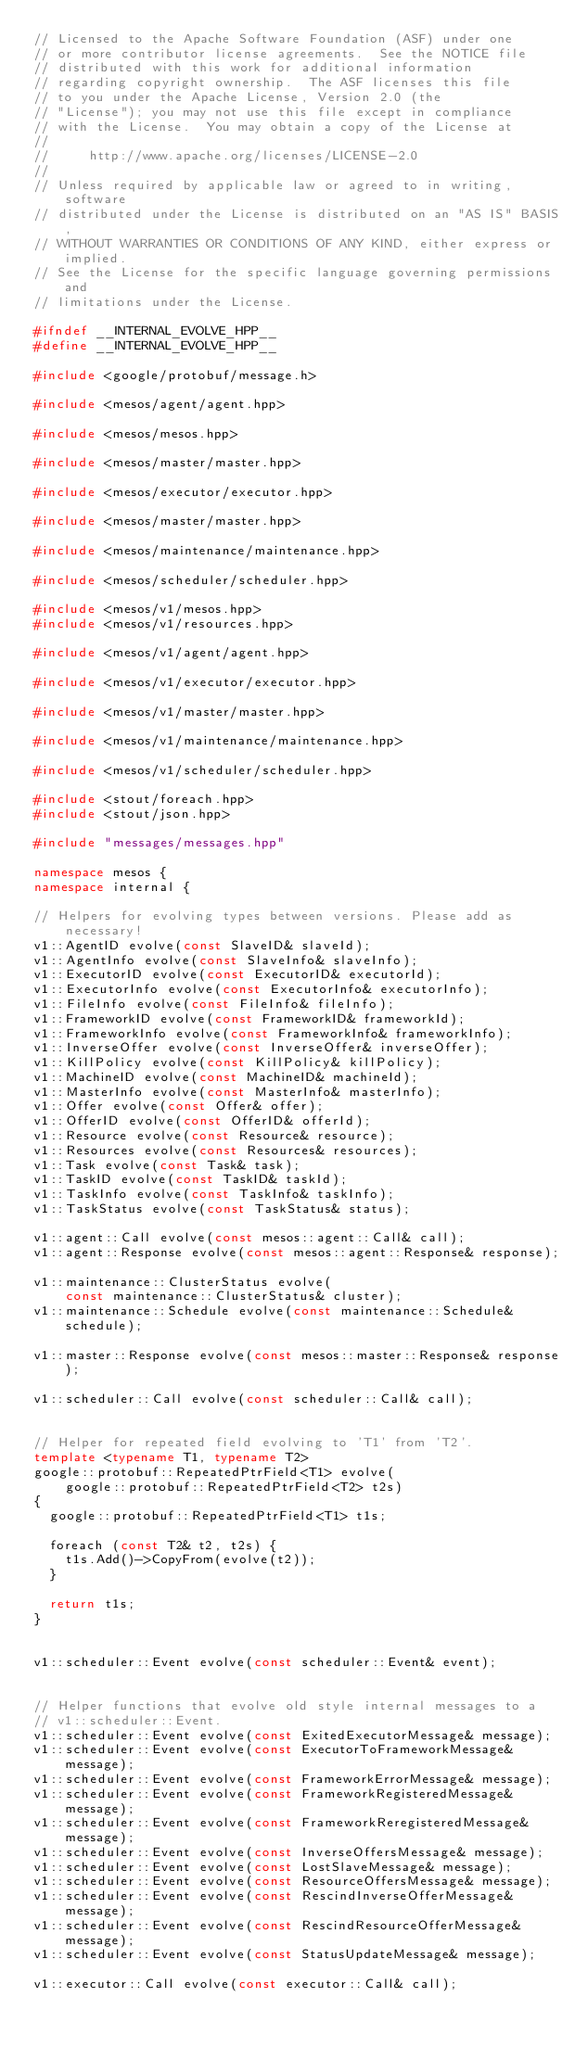Convert code to text. <code><loc_0><loc_0><loc_500><loc_500><_C++_>// Licensed to the Apache Software Foundation (ASF) under one
// or more contributor license agreements.  See the NOTICE file
// distributed with this work for additional information
// regarding copyright ownership.  The ASF licenses this file
// to you under the Apache License, Version 2.0 (the
// "License"); you may not use this file except in compliance
// with the License.  You may obtain a copy of the License at
//
//     http://www.apache.org/licenses/LICENSE-2.0
//
// Unless required by applicable law or agreed to in writing, software
// distributed under the License is distributed on an "AS IS" BASIS,
// WITHOUT WARRANTIES OR CONDITIONS OF ANY KIND, either express or implied.
// See the License for the specific language governing permissions and
// limitations under the License.

#ifndef __INTERNAL_EVOLVE_HPP__
#define __INTERNAL_EVOLVE_HPP__

#include <google/protobuf/message.h>

#include <mesos/agent/agent.hpp>

#include <mesos/mesos.hpp>

#include <mesos/master/master.hpp>

#include <mesos/executor/executor.hpp>

#include <mesos/master/master.hpp>

#include <mesos/maintenance/maintenance.hpp>

#include <mesos/scheduler/scheduler.hpp>

#include <mesos/v1/mesos.hpp>
#include <mesos/v1/resources.hpp>

#include <mesos/v1/agent/agent.hpp>

#include <mesos/v1/executor/executor.hpp>

#include <mesos/v1/master/master.hpp>

#include <mesos/v1/maintenance/maintenance.hpp>

#include <mesos/v1/scheduler/scheduler.hpp>

#include <stout/foreach.hpp>
#include <stout/json.hpp>

#include "messages/messages.hpp"

namespace mesos {
namespace internal {

// Helpers for evolving types between versions. Please add as necessary!
v1::AgentID evolve(const SlaveID& slaveId);
v1::AgentInfo evolve(const SlaveInfo& slaveInfo);
v1::ExecutorID evolve(const ExecutorID& executorId);
v1::ExecutorInfo evolve(const ExecutorInfo& executorInfo);
v1::FileInfo evolve(const FileInfo& fileInfo);
v1::FrameworkID evolve(const FrameworkID& frameworkId);
v1::FrameworkInfo evolve(const FrameworkInfo& frameworkInfo);
v1::InverseOffer evolve(const InverseOffer& inverseOffer);
v1::KillPolicy evolve(const KillPolicy& killPolicy);
v1::MachineID evolve(const MachineID& machineId);
v1::MasterInfo evolve(const MasterInfo& masterInfo);
v1::Offer evolve(const Offer& offer);
v1::OfferID evolve(const OfferID& offerId);
v1::Resource evolve(const Resource& resource);
v1::Resources evolve(const Resources& resources);
v1::Task evolve(const Task& task);
v1::TaskID evolve(const TaskID& taskId);
v1::TaskInfo evolve(const TaskInfo& taskInfo);
v1::TaskStatus evolve(const TaskStatus& status);

v1::agent::Call evolve(const mesos::agent::Call& call);
v1::agent::Response evolve(const mesos::agent::Response& response);

v1::maintenance::ClusterStatus evolve(
    const maintenance::ClusterStatus& cluster);
v1::maintenance::Schedule evolve(const maintenance::Schedule& schedule);

v1::master::Response evolve(const mesos::master::Response& response);

v1::scheduler::Call evolve(const scheduler::Call& call);


// Helper for repeated field evolving to 'T1' from 'T2'.
template <typename T1, typename T2>
google::protobuf::RepeatedPtrField<T1> evolve(
    google::protobuf::RepeatedPtrField<T2> t2s)
{
  google::protobuf::RepeatedPtrField<T1> t1s;

  foreach (const T2& t2, t2s) {
    t1s.Add()->CopyFrom(evolve(t2));
  }

  return t1s;
}


v1::scheduler::Event evolve(const scheduler::Event& event);


// Helper functions that evolve old style internal messages to a
// v1::scheduler::Event.
v1::scheduler::Event evolve(const ExitedExecutorMessage& message);
v1::scheduler::Event evolve(const ExecutorToFrameworkMessage& message);
v1::scheduler::Event evolve(const FrameworkErrorMessage& message);
v1::scheduler::Event evolve(const FrameworkRegisteredMessage& message);
v1::scheduler::Event evolve(const FrameworkReregisteredMessage& message);
v1::scheduler::Event evolve(const InverseOffersMessage& message);
v1::scheduler::Event evolve(const LostSlaveMessage& message);
v1::scheduler::Event evolve(const ResourceOffersMessage& message);
v1::scheduler::Event evolve(const RescindInverseOfferMessage& message);
v1::scheduler::Event evolve(const RescindResourceOfferMessage& message);
v1::scheduler::Event evolve(const StatusUpdateMessage& message);

v1::executor::Call evolve(const executor::Call& call);</code> 